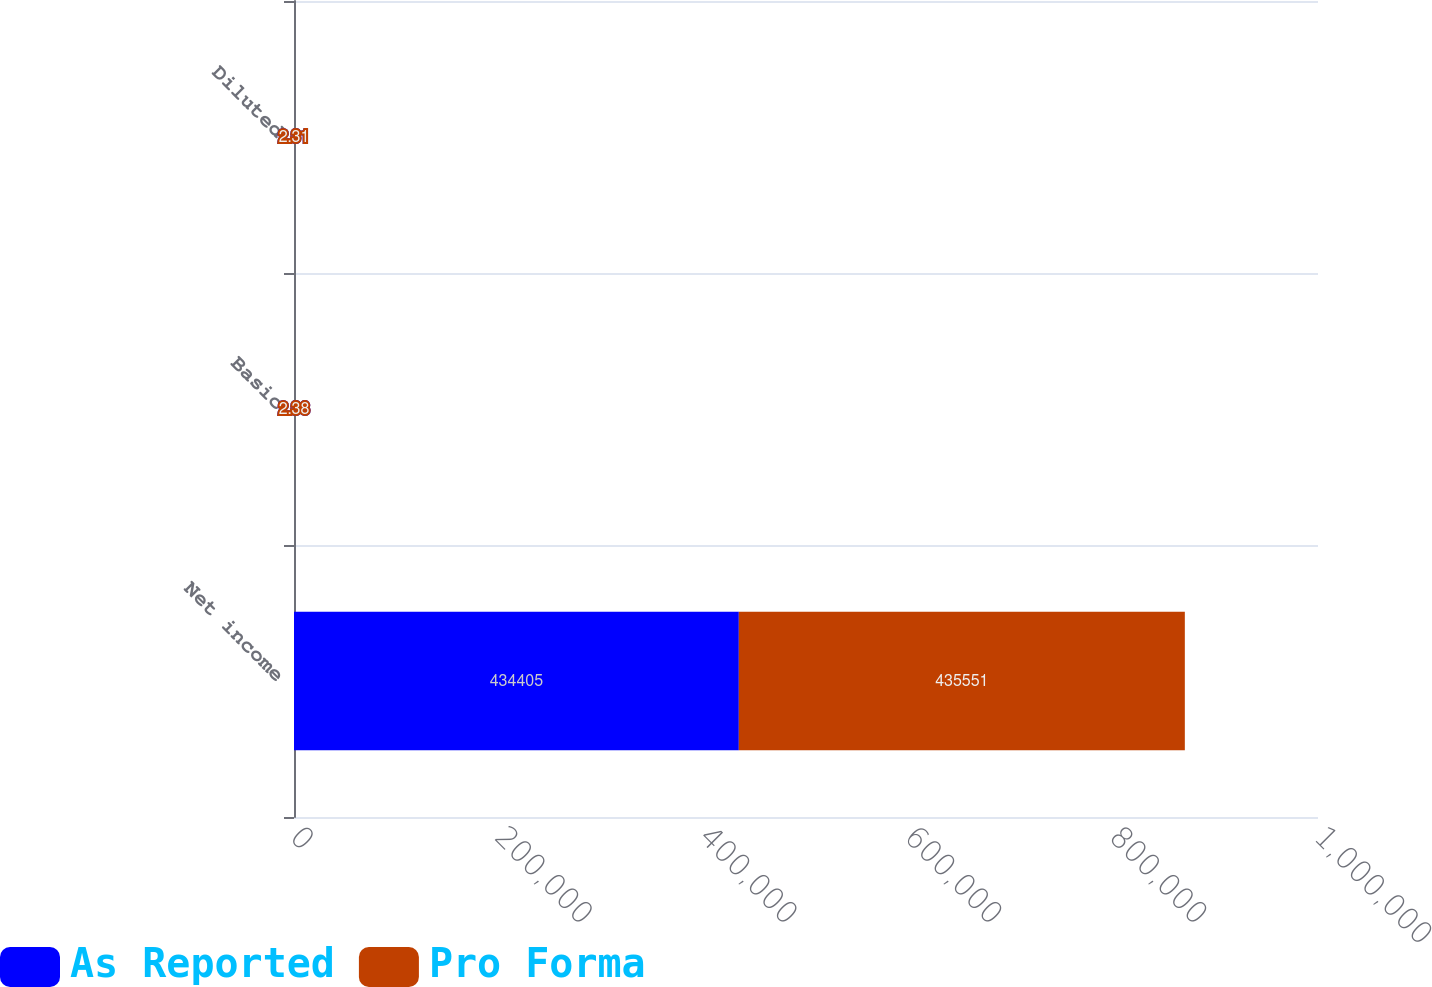<chart> <loc_0><loc_0><loc_500><loc_500><stacked_bar_chart><ecel><fcel>Net income<fcel>Basic<fcel>Diluted<nl><fcel>As Reported<fcel>434405<fcel>2.38<fcel>2.31<nl><fcel>Pro Forma<fcel>435551<fcel>2.38<fcel>2.31<nl></chart> 